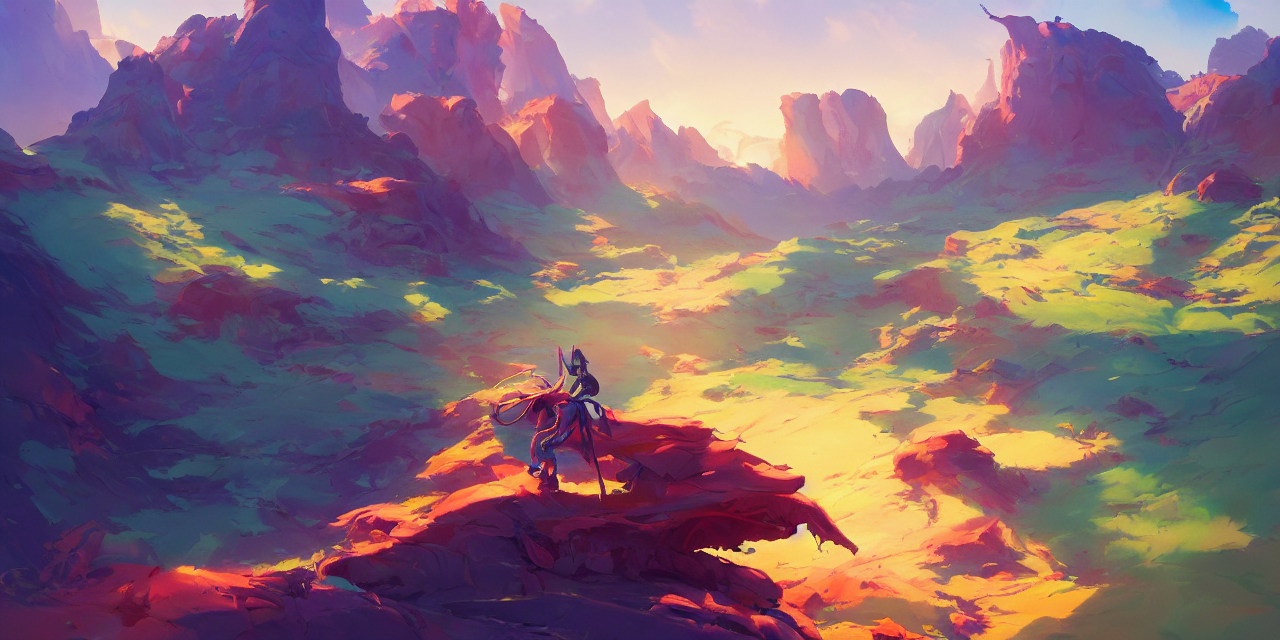Is the frame of the image well-composed? The composition of the image is visually striking, with a well-balanced layout that uses contrasting colors and depth to guide the eye effortlessly across the scene. The lone figure looking out over the landscape adds a sense of narrative and scale, creating a compelling focal point that is well-positioned within the frame to draw the viewer into the expansive terrain. 